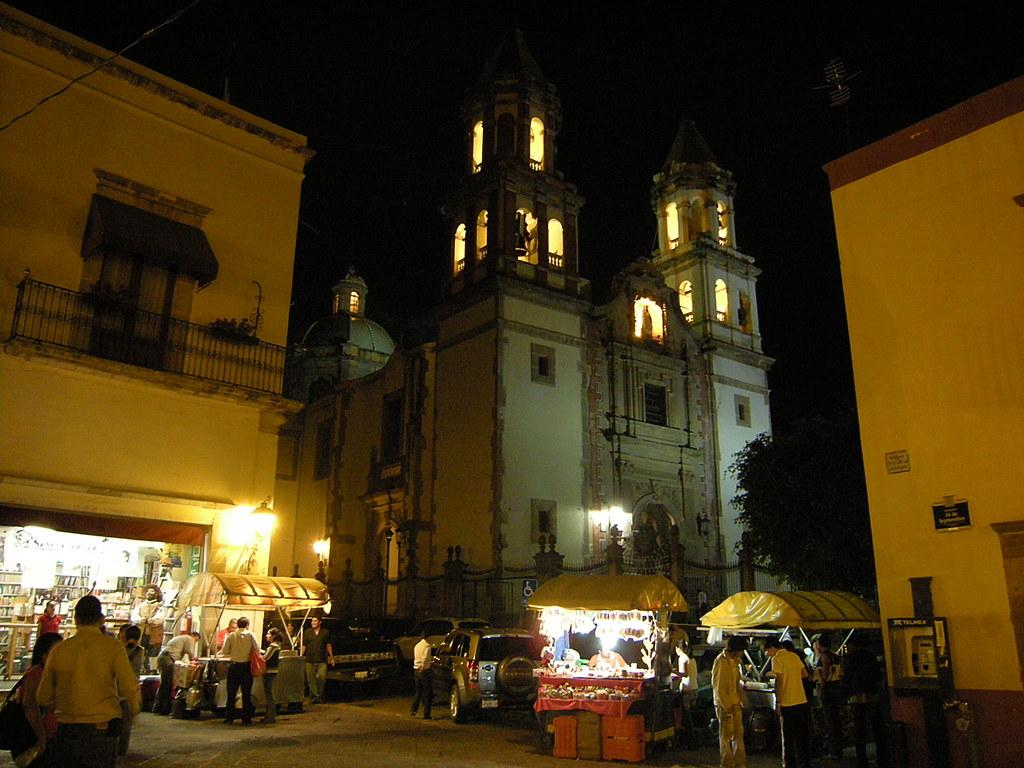What is located in the center of the image? There are vehicles in the center of the image. What else can be seen in the image besides the vehicles? There are people standing in the image. What is visible in the background of the image? There are buildings in the background of the image. What type of vegetation is on the right side of the image? There is a tree on the right side of the image. What type of food is being served in the town depicted in the image? There is no town or food present in the image; it features vehicles, people, buildings, and a tree. What type of system is responsible for the organization of the vehicles in the image? There is no system mentioned or depicted in the image; it simply shows vehicles, people, buildings, and a tree. 